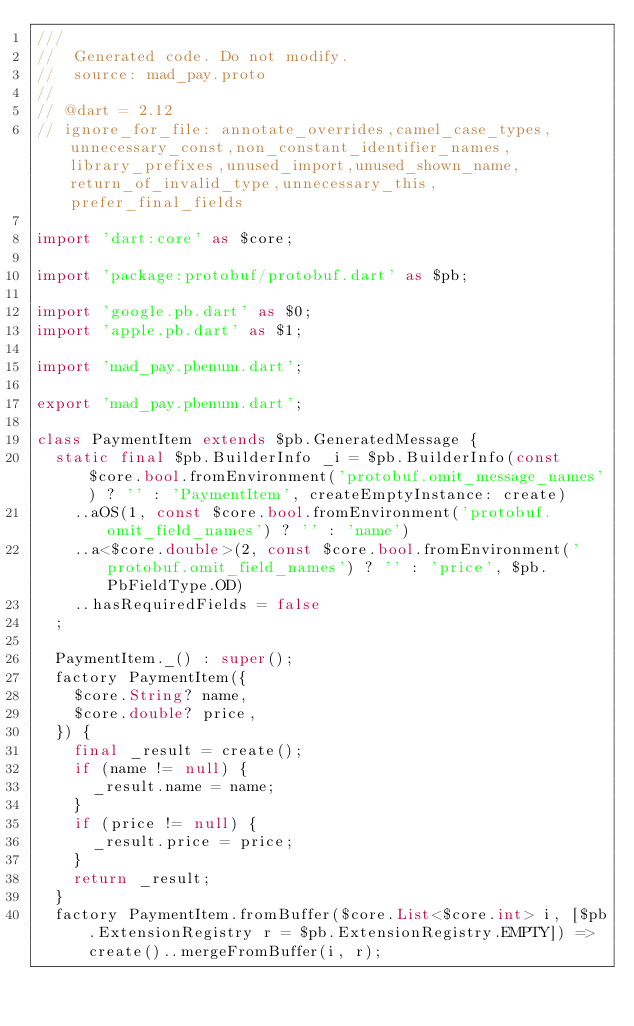<code> <loc_0><loc_0><loc_500><loc_500><_Dart_>///
//  Generated code. Do not modify.
//  source: mad_pay.proto
//
// @dart = 2.12
// ignore_for_file: annotate_overrides,camel_case_types,unnecessary_const,non_constant_identifier_names,library_prefixes,unused_import,unused_shown_name,return_of_invalid_type,unnecessary_this,prefer_final_fields

import 'dart:core' as $core;

import 'package:protobuf/protobuf.dart' as $pb;

import 'google.pb.dart' as $0;
import 'apple.pb.dart' as $1;

import 'mad_pay.pbenum.dart';

export 'mad_pay.pbenum.dart';

class PaymentItem extends $pb.GeneratedMessage {
  static final $pb.BuilderInfo _i = $pb.BuilderInfo(const $core.bool.fromEnvironment('protobuf.omit_message_names') ? '' : 'PaymentItem', createEmptyInstance: create)
    ..aOS(1, const $core.bool.fromEnvironment('protobuf.omit_field_names') ? '' : 'name')
    ..a<$core.double>(2, const $core.bool.fromEnvironment('protobuf.omit_field_names') ? '' : 'price', $pb.PbFieldType.OD)
    ..hasRequiredFields = false
  ;

  PaymentItem._() : super();
  factory PaymentItem({
    $core.String? name,
    $core.double? price,
  }) {
    final _result = create();
    if (name != null) {
      _result.name = name;
    }
    if (price != null) {
      _result.price = price;
    }
    return _result;
  }
  factory PaymentItem.fromBuffer($core.List<$core.int> i, [$pb.ExtensionRegistry r = $pb.ExtensionRegistry.EMPTY]) => create()..mergeFromBuffer(i, r);</code> 